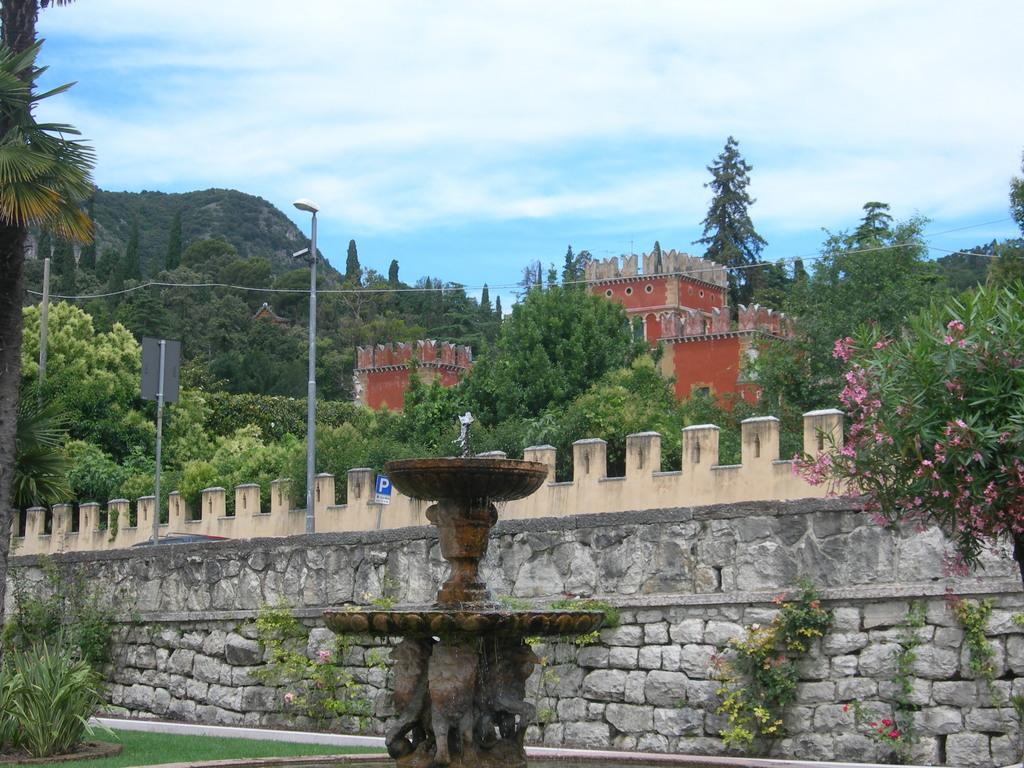What type of boundary is shown in the image? The image depicts a border. What structure can be seen near the border? There is a building in the image. What type of vegetation is present in the image? Trees and grass are visible in the image. What type of man-made structure is present in the image? A light pole is visible in the image. What type of infrastructure is present in the image? Electrical wires are in the image. What type of plant is present in the image? There is a plant in the image. What type of natural feature is present in the image? There is a mountain in the image. What is the weather like in the image? The sky is cloudy in the image. What type of water feature is present in the image? There is a water fountain in the image. Where is the sheet used for recess in the image? There is no sheet or recess present in the image. What type of sail can be seen on the mountain in the image? There is no sail present in the image, as it features a mountain and not a sailing vessel. 